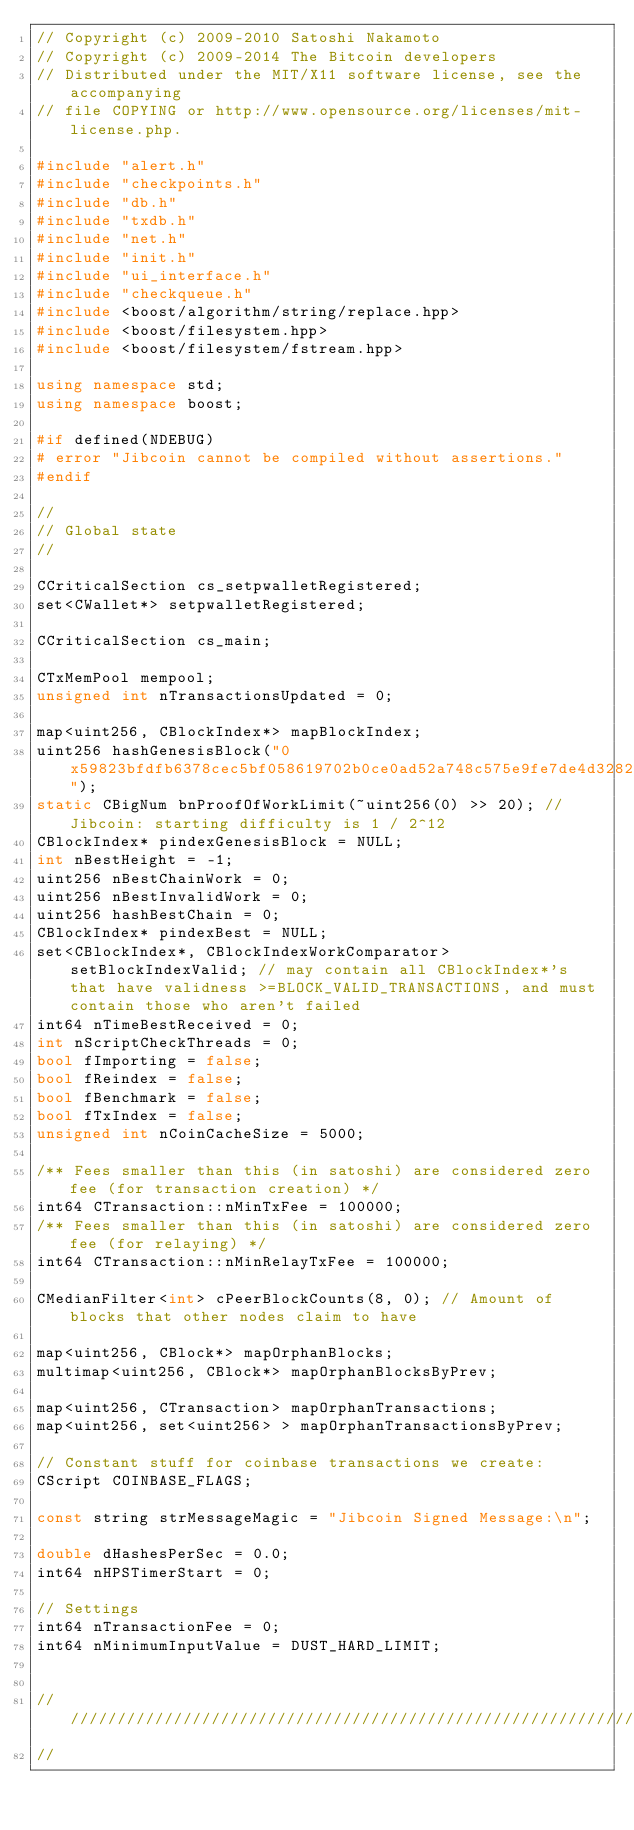Convert code to text. <code><loc_0><loc_0><loc_500><loc_500><_C++_>// Copyright (c) 2009-2010 Satoshi Nakamoto
// Copyright (c) 2009-2014 The Bitcoin developers
// Distributed under the MIT/X11 software license, see the accompanying
// file COPYING or http://www.opensource.org/licenses/mit-license.php.

#include "alert.h"
#include "checkpoints.h"
#include "db.h"
#include "txdb.h"
#include "net.h"
#include "init.h"
#include "ui_interface.h"
#include "checkqueue.h"
#include <boost/algorithm/string/replace.hpp>
#include <boost/filesystem.hpp>
#include <boost/filesystem/fstream.hpp>

using namespace std;
using namespace boost;

#if defined(NDEBUG)
# error "Jibcoin cannot be compiled without assertions."
#endif

//
// Global state
//

CCriticalSection cs_setpwalletRegistered;
set<CWallet*> setpwalletRegistered;

CCriticalSection cs_main;

CTxMemPool mempool;
unsigned int nTransactionsUpdated = 0;

map<uint256, CBlockIndex*> mapBlockIndex;
uint256 hashGenesisBlock("0x59823bfdfb6378cec5bf058619702b0ce0ad52a748c575e9fe7de4d328224d47");
static CBigNum bnProofOfWorkLimit(~uint256(0) >> 20); // Jibcoin: starting difficulty is 1 / 2^12
CBlockIndex* pindexGenesisBlock = NULL;
int nBestHeight = -1;
uint256 nBestChainWork = 0;
uint256 nBestInvalidWork = 0;
uint256 hashBestChain = 0;
CBlockIndex* pindexBest = NULL;
set<CBlockIndex*, CBlockIndexWorkComparator> setBlockIndexValid; // may contain all CBlockIndex*'s that have validness >=BLOCK_VALID_TRANSACTIONS, and must contain those who aren't failed
int64 nTimeBestReceived = 0;
int nScriptCheckThreads = 0;
bool fImporting = false;
bool fReindex = false;
bool fBenchmark = false;
bool fTxIndex = false;
unsigned int nCoinCacheSize = 5000;

/** Fees smaller than this (in satoshi) are considered zero fee (for transaction creation) */
int64 CTransaction::nMinTxFee = 100000;
/** Fees smaller than this (in satoshi) are considered zero fee (for relaying) */
int64 CTransaction::nMinRelayTxFee = 100000;

CMedianFilter<int> cPeerBlockCounts(8, 0); // Amount of blocks that other nodes claim to have

map<uint256, CBlock*> mapOrphanBlocks;
multimap<uint256, CBlock*> mapOrphanBlocksByPrev;

map<uint256, CTransaction> mapOrphanTransactions;
map<uint256, set<uint256> > mapOrphanTransactionsByPrev;

// Constant stuff for coinbase transactions we create:
CScript COINBASE_FLAGS;

const string strMessageMagic = "Jibcoin Signed Message:\n";

double dHashesPerSec = 0.0;
int64 nHPSTimerStart = 0;

// Settings
int64 nTransactionFee = 0;
int64 nMinimumInputValue = DUST_HARD_LIMIT;


//////////////////////////////////////////////////////////////////////////////
//</code> 